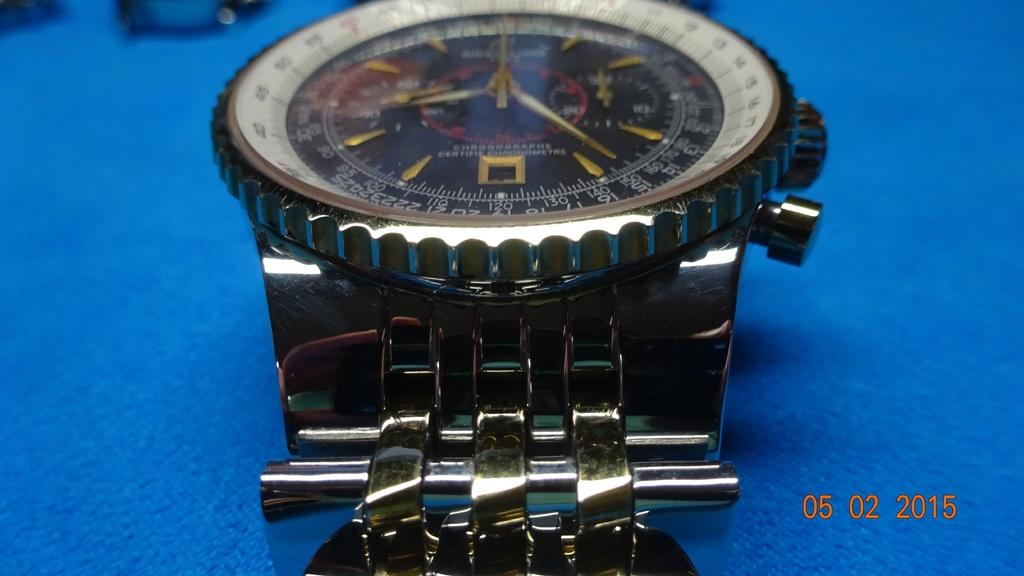Provide a one-sentence caption for the provided image. A wrist watch reading 8:25 sits on a table. 